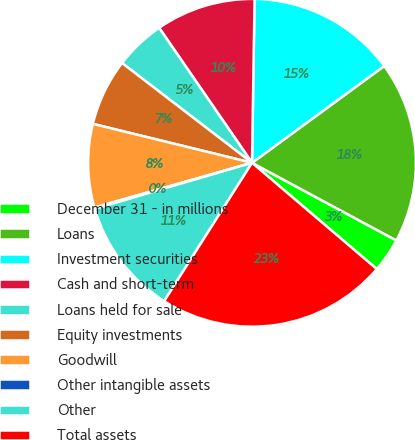Convert chart. <chart><loc_0><loc_0><loc_500><loc_500><pie_chart><fcel>December 31 - in millions<fcel>Loans<fcel>Investment securities<fcel>Cash and short-term<fcel>Loans held for sale<fcel>Equity investments<fcel>Goodwill<fcel>Other intangible assets<fcel>Other<fcel>Total assets<nl><fcel>3.37%<fcel>17.92%<fcel>14.69%<fcel>9.84%<fcel>4.99%<fcel>6.6%<fcel>8.22%<fcel>0.13%<fcel>11.46%<fcel>22.78%<nl></chart> 